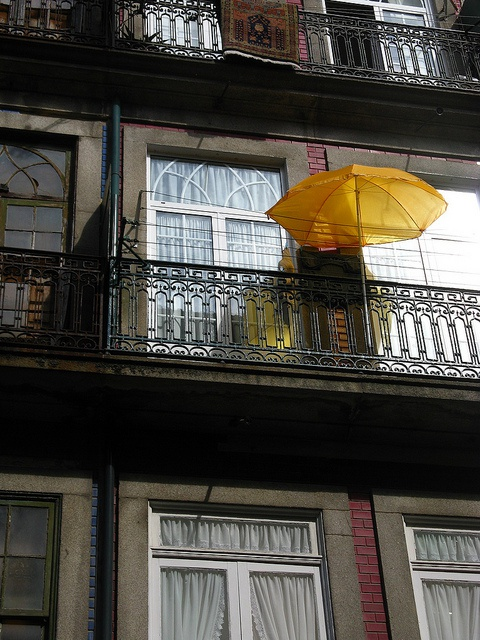Describe the objects in this image and their specific colors. I can see a umbrella in gray, olive, orange, tan, and khaki tones in this image. 